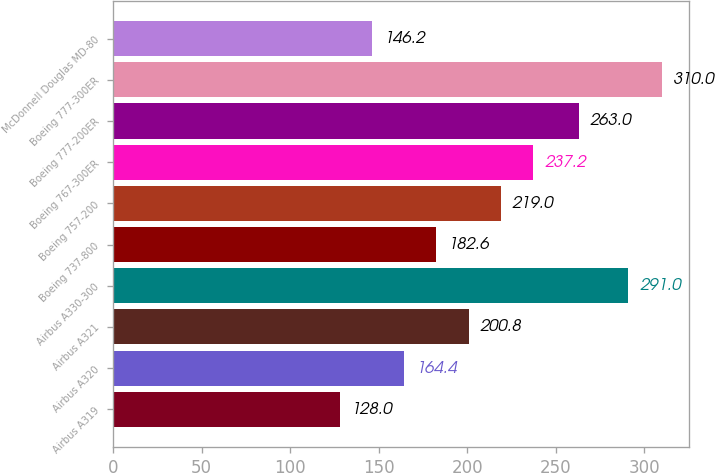<chart> <loc_0><loc_0><loc_500><loc_500><bar_chart><fcel>Airbus A319<fcel>Airbus A320<fcel>Airbus A321<fcel>Airbus A330-300<fcel>Boeing 737-800<fcel>Boeing 757-200<fcel>Boeing 767-300ER<fcel>Boeing 777-200ER<fcel>Boeing 777-300ER<fcel>McDonnell Douglas MD-80<nl><fcel>128<fcel>164.4<fcel>200.8<fcel>291<fcel>182.6<fcel>219<fcel>237.2<fcel>263<fcel>310<fcel>146.2<nl></chart> 